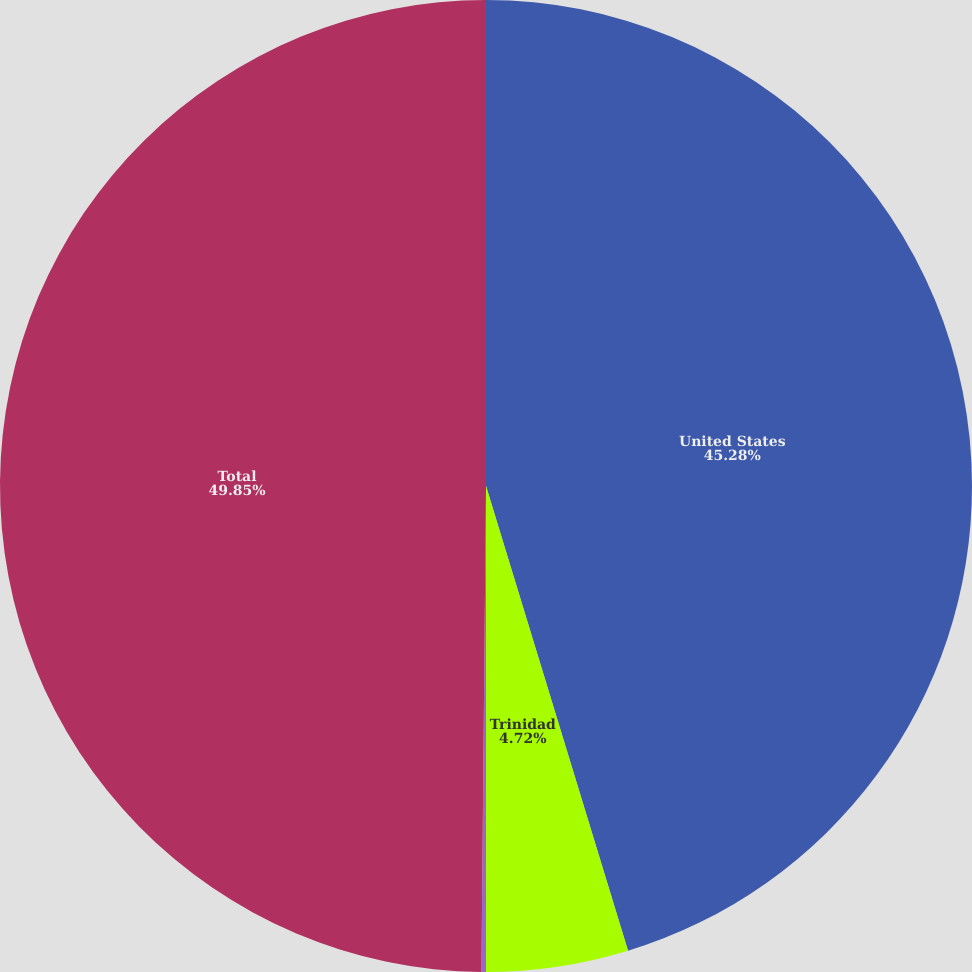<chart> <loc_0><loc_0><loc_500><loc_500><pie_chart><fcel>United States<fcel>Trinidad<fcel>Canada<fcel>Total<nl><fcel>45.28%<fcel>4.72%<fcel>0.15%<fcel>49.85%<nl></chart> 